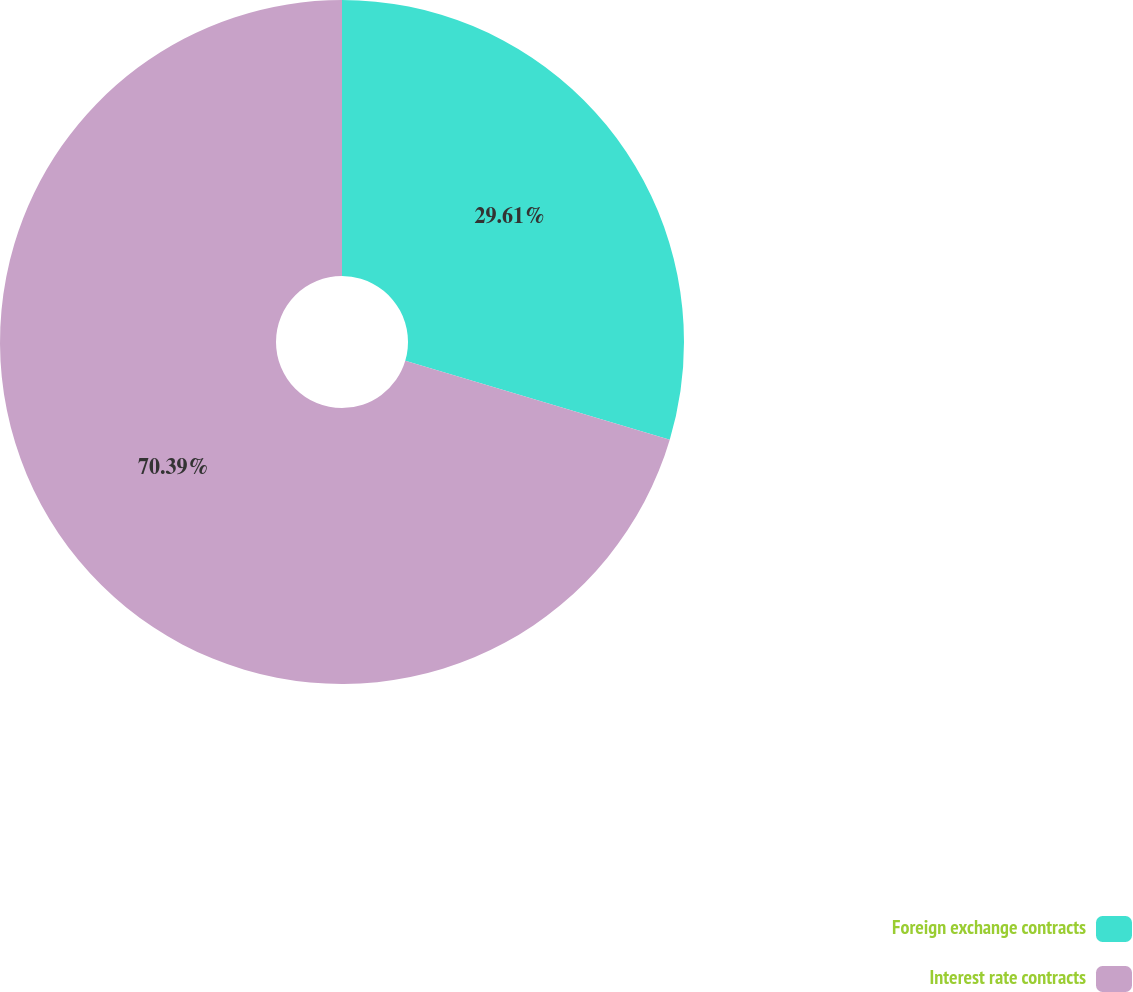<chart> <loc_0><loc_0><loc_500><loc_500><pie_chart><fcel>Foreign exchange contracts<fcel>Interest rate contracts<nl><fcel>29.61%<fcel>70.39%<nl></chart> 